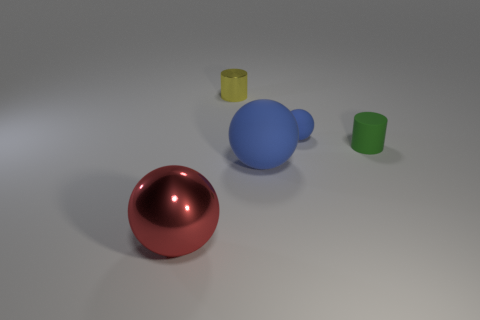Subtract all gray blocks. How many blue balls are left? 2 Subtract all blue rubber balls. How many balls are left? 1 Add 3 tiny rubber objects. How many objects exist? 8 Subtract all cylinders. How many objects are left? 3 Subtract all brown spheres. Subtract all brown cylinders. How many spheres are left? 3 Subtract 1 yellow cylinders. How many objects are left? 4 Subtract all large matte objects. Subtract all purple cubes. How many objects are left? 4 Add 4 green rubber objects. How many green rubber objects are left? 5 Add 3 tiny red metal cubes. How many tiny red metal cubes exist? 3 